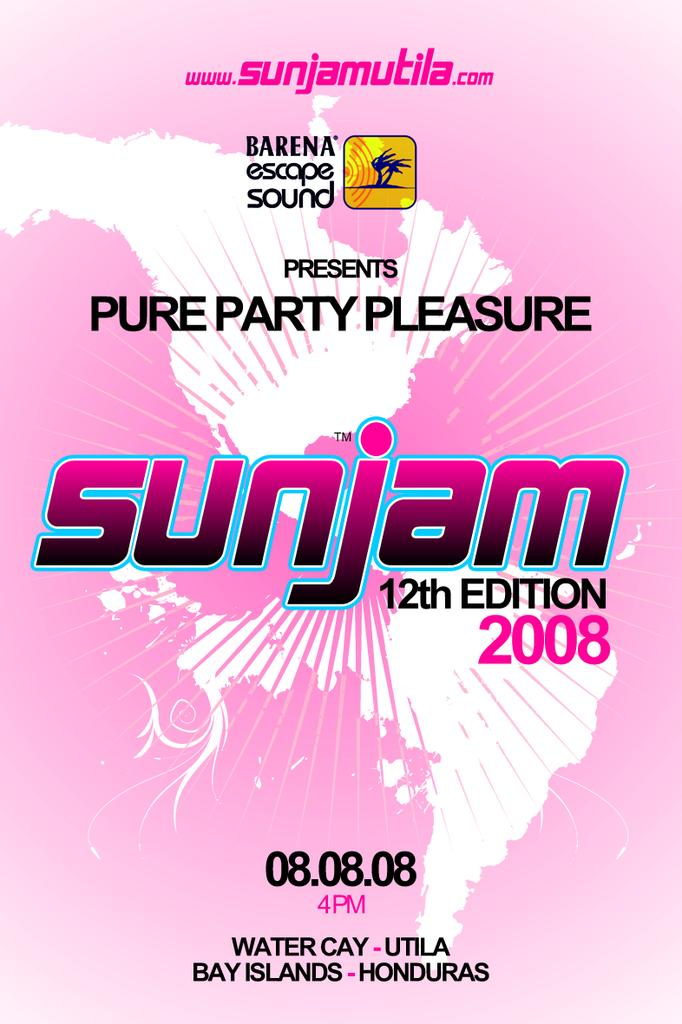<image>
Summarize the visual content of the image. pink poster showing north and south america for sunjam 2008 